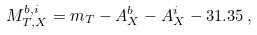Convert formula to latex. <formula><loc_0><loc_0><loc_500><loc_500>M _ { T , X } ^ { b , i } = m _ { T } - A _ { X } ^ { b } - A _ { X } ^ { i } - 3 1 . 3 5 \, ,</formula> 